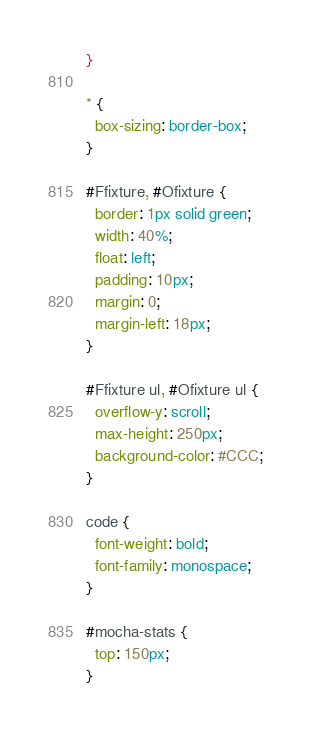Convert code to text. <code><loc_0><loc_0><loc_500><loc_500><_CSS_>}

* {
  box-sizing: border-box;
}

#Ffixture, #Ofixture {
  border: 1px solid green;
  width: 40%;
  float: left;
  padding: 10px;
  margin: 0;
  margin-left: 18px;
}

#Ffixture ul, #Ofixture ul {
  overflow-y: scroll;
  max-height: 250px;
  background-color: #CCC;
}

code {
  font-weight: bold;
  font-family: monospace;
}

#mocha-stats {
  top: 150px;
}</code> 